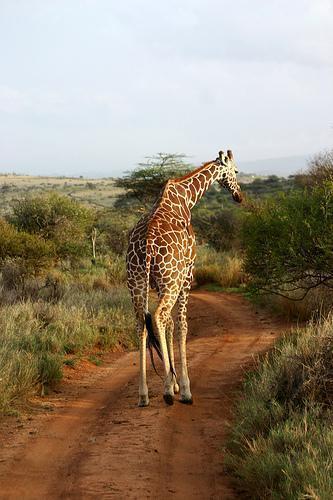How many giraffes are there?
Give a very brief answer. 1. 